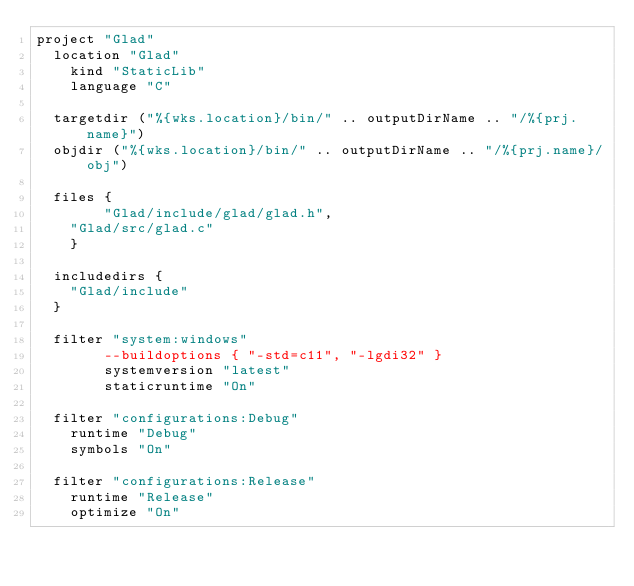<code> <loc_0><loc_0><loc_500><loc_500><_Lua_>project "Glad"
	location "Glad"
    kind "StaticLib"
    language "C"
    
	targetdir ("%{wks.location}/bin/" .. outputDirName .. "/%{prj.name}")
	objdir ("%{wks.location}/bin/" .. outputDirName .. "/%{prj.name}/obj")

	files {
        "Glad/include/glad/glad.h",
		"Glad/src/glad.c"
    }
	
	includedirs {
		"Glad/include"
	}
    
	filter "system:windows"
        --buildoptions { "-std=c11", "-lgdi32" }
        systemversion "latest"
        staticruntime "On"
		
	filter "configurations:Debug"
		runtime "Debug"
		symbols "On"

	filter "configurations:Release"
		runtime "Release"
		optimize "On"</code> 